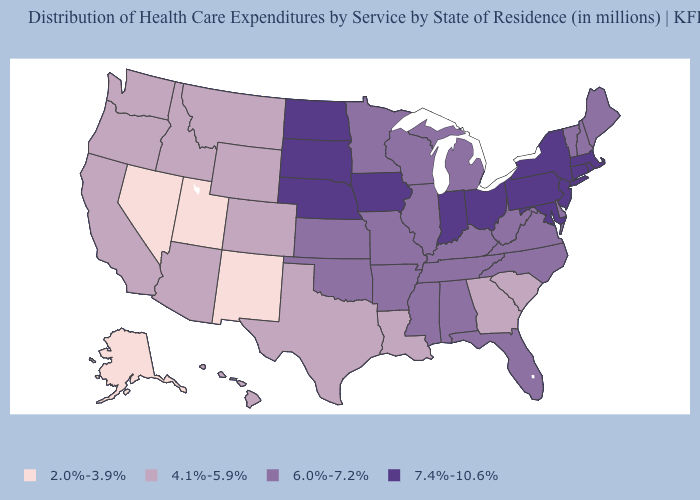Does West Virginia have the highest value in the USA?
Keep it brief. No. What is the value of Maryland?
Answer briefly. 7.4%-10.6%. Is the legend a continuous bar?
Give a very brief answer. No. Name the states that have a value in the range 2.0%-3.9%?
Quick response, please. Alaska, Nevada, New Mexico, Utah. Name the states that have a value in the range 4.1%-5.9%?
Short answer required. Arizona, California, Colorado, Georgia, Hawaii, Idaho, Louisiana, Montana, Oregon, South Carolina, Texas, Washington, Wyoming. Does Connecticut have the lowest value in the USA?
Write a very short answer. No. What is the value of South Carolina?
Be succinct. 4.1%-5.9%. Is the legend a continuous bar?
Short answer required. No. Does Maryland have the highest value in the South?
Write a very short answer. Yes. Does the map have missing data?
Short answer required. No. Does Delaware have the lowest value in the USA?
Write a very short answer. No. Does West Virginia have a lower value than Washington?
Keep it brief. No. Does Alaska have the same value as Nevada?
Short answer required. Yes. Name the states that have a value in the range 6.0%-7.2%?
Give a very brief answer. Alabama, Arkansas, Delaware, Florida, Illinois, Kansas, Kentucky, Maine, Michigan, Minnesota, Mississippi, Missouri, New Hampshire, North Carolina, Oklahoma, Tennessee, Vermont, Virginia, West Virginia, Wisconsin. What is the value of Iowa?
Give a very brief answer. 7.4%-10.6%. 